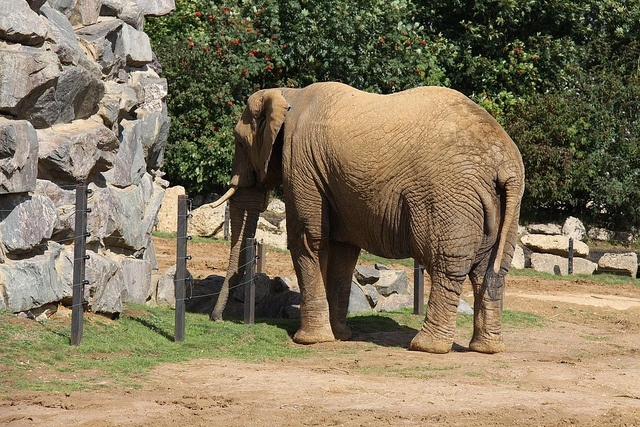Describe the objects in this image and their specific colors. I can see a elephant in lightgray, black, tan, and gray tones in this image. 